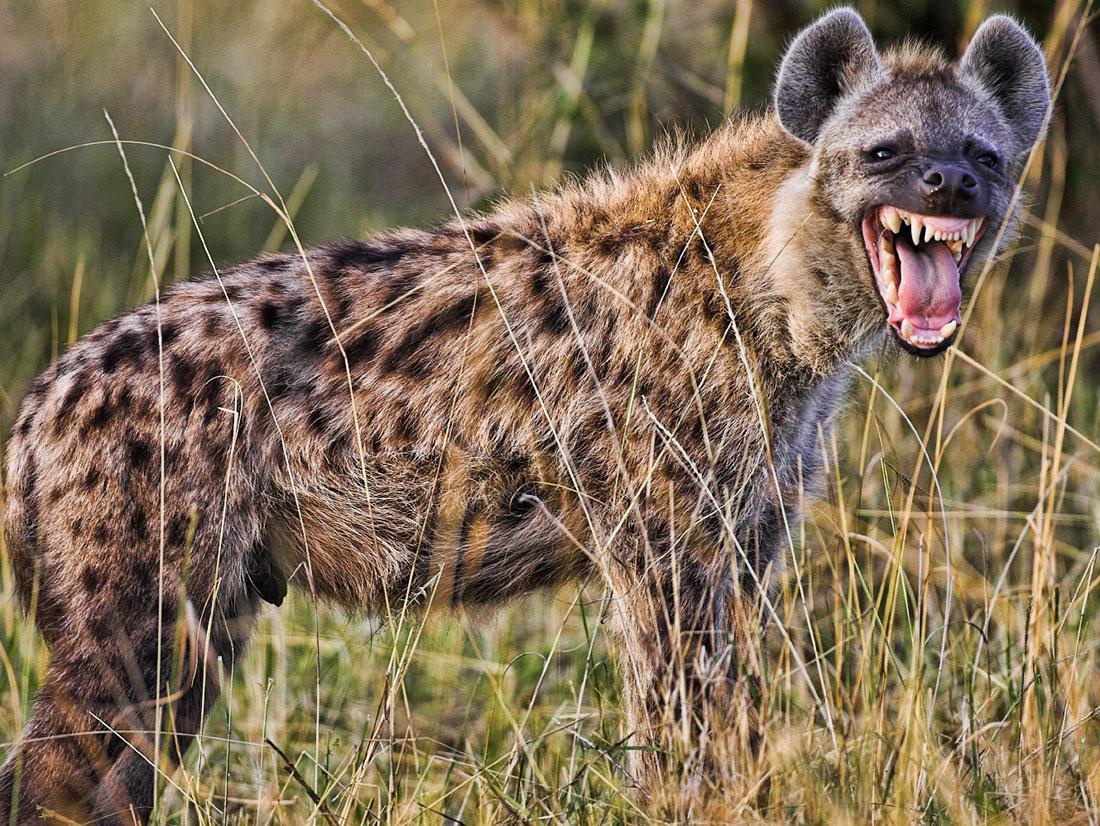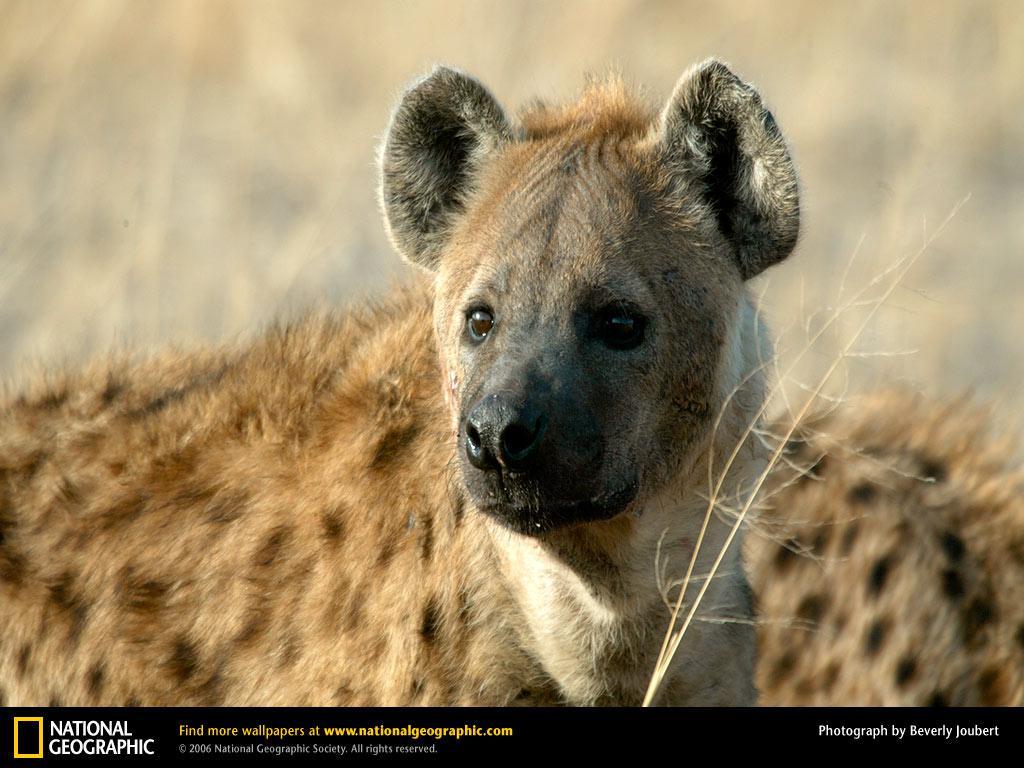The first image is the image on the left, the second image is the image on the right. Assess this claim about the two images: "One image shows a hyena baring its fangs in a wide-opened mouth.". Correct or not? Answer yes or no. Yes. The first image is the image on the left, the second image is the image on the right. Considering the images on both sides, is "A hyena has its mouth wide open with sharp teeth visible." valid? Answer yes or no. Yes. 